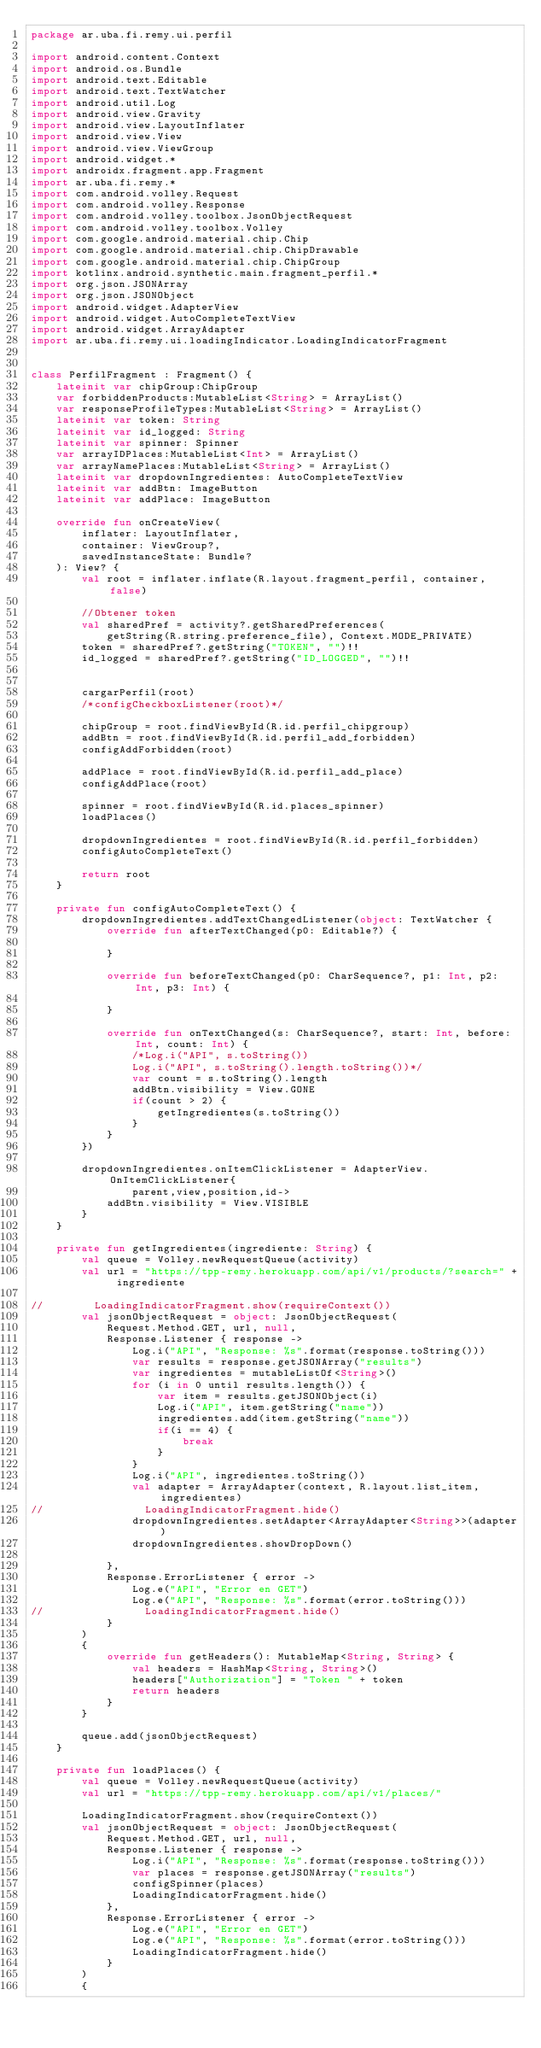<code> <loc_0><loc_0><loc_500><loc_500><_Kotlin_>package ar.uba.fi.remy.ui.perfil

import android.content.Context
import android.os.Bundle
import android.text.Editable
import android.text.TextWatcher
import android.util.Log
import android.view.Gravity
import android.view.LayoutInflater
import android.view.View
import android.view.ViewGroup
import android.widget.*
import androidx.fragment.app.Fragment
import ar.uba.fi.remy.*
import com.android.volley.Request
import com.android.volley.Response
import com.android.volley.toolbox.JsonObjectRequest
import com.android.volley.toolbox.Volley
import com.google.android.material.chip.Chip
import com.google.android.material.chip.ChipDrawable
import com.google.android.material.chip.ChipGroup
import kotlinx.android.synthetic.main.fragment_perfil.*
import org.json.JSONArray
import org.json.JSONObject
import android.widget.AdapterView
import android.widget.AutoCompleteTextView
import android.widget.ArrayAdapter
import ar.uba.fi.remy.ui.loadingIndicator.LoadingIndicatorFragment


class PerfilFragment : Fragment() {
    lateinit var chipGroup:ChipGroup
    var forbiddenProducts:MutableList<String> = ArrayList()
    var responseProfileTypes:MutableList<String> = ArrayList()
    lateinit var token: String
    lateinit var id_logged: String
    lateinit var spinner: Spinner
    var arrayIDPlaces:MutableList<Int> = ArrayList()
    var arrayNamePlaces:MutableList<String> = ArrayList()
    lateinit var dropdownIngredientes: AutoCompleteTextView
    lateinit var addBtn: ImageButton
    lateinit var addPlace: ImageButton

    override fun onCreateView(
        inflater: LayoutInflater,
        container: ViewGroup?,
        savedInstanceState: Bundle?
    ): View? {
        val root = inflater.inflate(R.layout.fragment_perfil, container, false)

        //Obtener token
        val sharedPref = activity?.getSharedPreferences(
            getString(R.string.preference_file), Context.MODE_PRIVATE)
        token = sharedPref?.getString("TOKEN", "")!!
        id_logged = sharedPref?.getString("ID_LOGGED", "")!!


        cargarPerfil(root)
        /*configCheckboxListener(root)*/

        chipGroup = root.findViewById(R.id.perfil_chipgroup)
        addBtn = root.findViewById(R.id.perfil_add_forbidden)
        configAddForbidden(root)

        addPlace = root.findViewById(R.id.perfil_add_place)
        configAddPlace(root)

        spinner = root.findViewById(R.id.places_spinner)
        loadPlaces()

        dropdownIngredientes = root.findViewById(R.id.perfil_forbidden)
        configAutoCompleteText()

        return root
    }

    private fun configAutoCompleteText() {
        dropdownIngredientes.addTextChangedListener(object: TextWatcher {
            override fun afterTextChanged(p0: Editable?) {

            }

            override fun beforeTextChanged(p0: CharSequence?, p1: Int, p2: Int, p3: Int) {

            }

            override fun onTextChanged(s: CharSequence?, start: Int, before: Int, count: Int) {
                /*Log.i("API", s.toString())
                Log.i("API", s.toString().length.toString())*/
                var count = s.toString().length
                addBtn.visibility = View.GONE
                if(count > 2) {
                    getIngredientes(s.toString())
                }
            }
        })

        dropdownIngredientes.onItemClickListener = AdapterView.OnItemClickListener{
                parent,view,position,id->
            addBtn.visibility = View.VISIBLE
        }
    }

    private fun getIngredientes(ingrediente: String) {
        val queue = Volley.newRequestQueue(activity)
        val url = "https://tpp-remy.herokuapp.com/api/v1/products/?search=" + ingrediente

//        LoadingIndicatorFragment.show(requireContext())
        val jsonObjectRequest = object: JsonObjectRequest(
            Request.Method.GET, url, null,
            Response.Listener { response ->
                Log.i("API", "Response: %s".format(response.toString()))
                var results = response.getJSONArray("results")
                var ingredientes = mutableListOf<String>()
                for (i in 0 until results.length()) {
                    var item = results.getJSONObject(i)
                    Log.i("API", item.getString("name"))
                    ingredientes.add(item.getString("name"))
                    if(i == 4) {
                        break
                    }
                }
                Log.i("API", ingredientes.toString())
                val adapter = ArrayAdapter(context, R.layout.list_item, ingredientes)
//                LoadingIndicatorFragment.hide()
                dropdownIngredientes.setAdapter<ArrayAdapter<String>>(adapter)
                dropdownIngredientes.showDropDown()

            },
            Response.ErrorListener { error ->
                Log.e("API", "Error en GET")
                Log.e("API", "Response: %s".format(error.toString()))
//                LoadingIndicatorFragment.hide()
            }
        )
        {
            override fun getHeaders(): MutableMap<String, String> {
                val headers = HashMap<String, String>()
                headers["Authorization"] = "Token " + token
                return headers
            }
        }

        queue.add(jsonObjectRequest)
    }

    private fun loadPlaces() {
        val queue = Volley.newRequestQueue(activity)
        val url = "https://tpp-remy.herokuapp.com/api/v1/places/"

        LoadingIndicatorFragment.show(requireContext())
        val jsonObjectRequest = object: JsonObjectRequest(
            Request.Method.GET, url, null,
            Response.Listener { response ->
                Log.i("API", "Response: %s".format(response.toString()))
                var places = response.getJSONArray("results")
                configSpinner(places)
                LoadingIndicatorFragment.hide()
            },
            Response.ErrorListener { error ->
                Log.e("API", "Error en GET")
                Log.e("API", "Response: %s".format(error.toString()))
                LoadingIndicatorFragment.hide()
            }
        )
        {</code> 